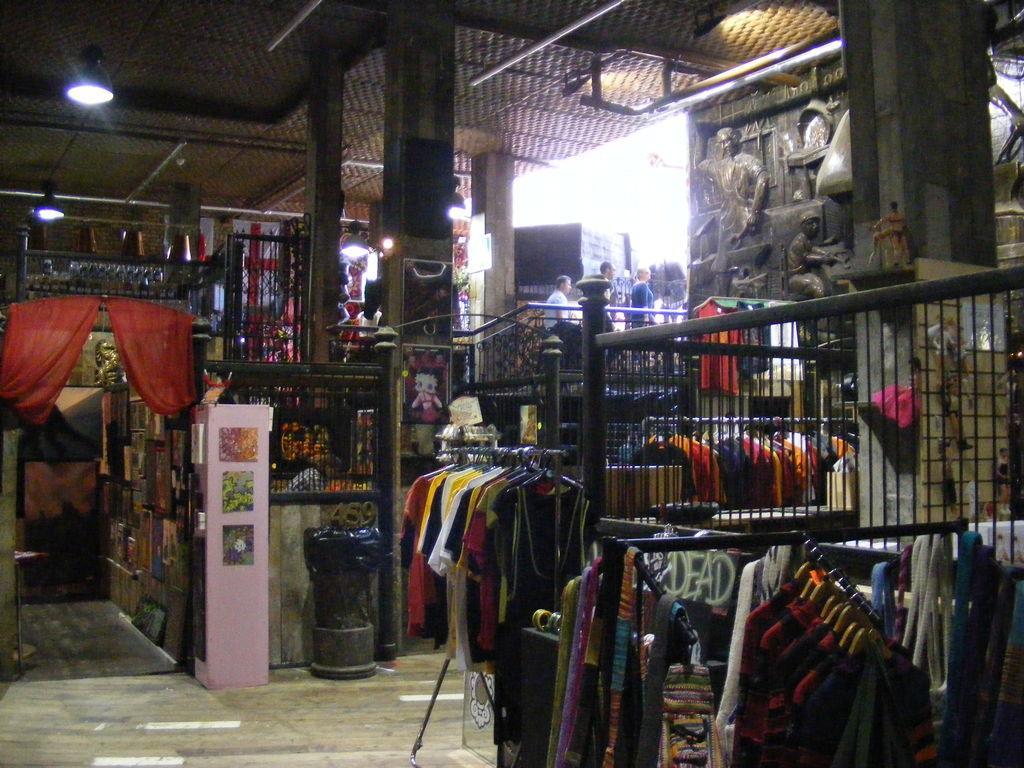Describe this image in one or two sentences. In this image I can see a store in which I can see the trailing, number of clothes hanged to the hangers, the red colored curtain, the ceiling, a light to the ceiling, few persons sitting, few sculptures of a person's, a dustbin, few photo frames attached to the wall and few other objects. 